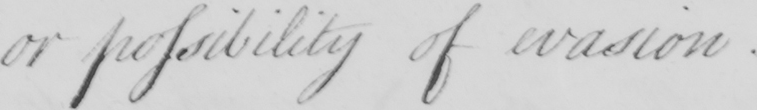Transcribe the text shown in this historical manuscript line. or possibility of evasion . 